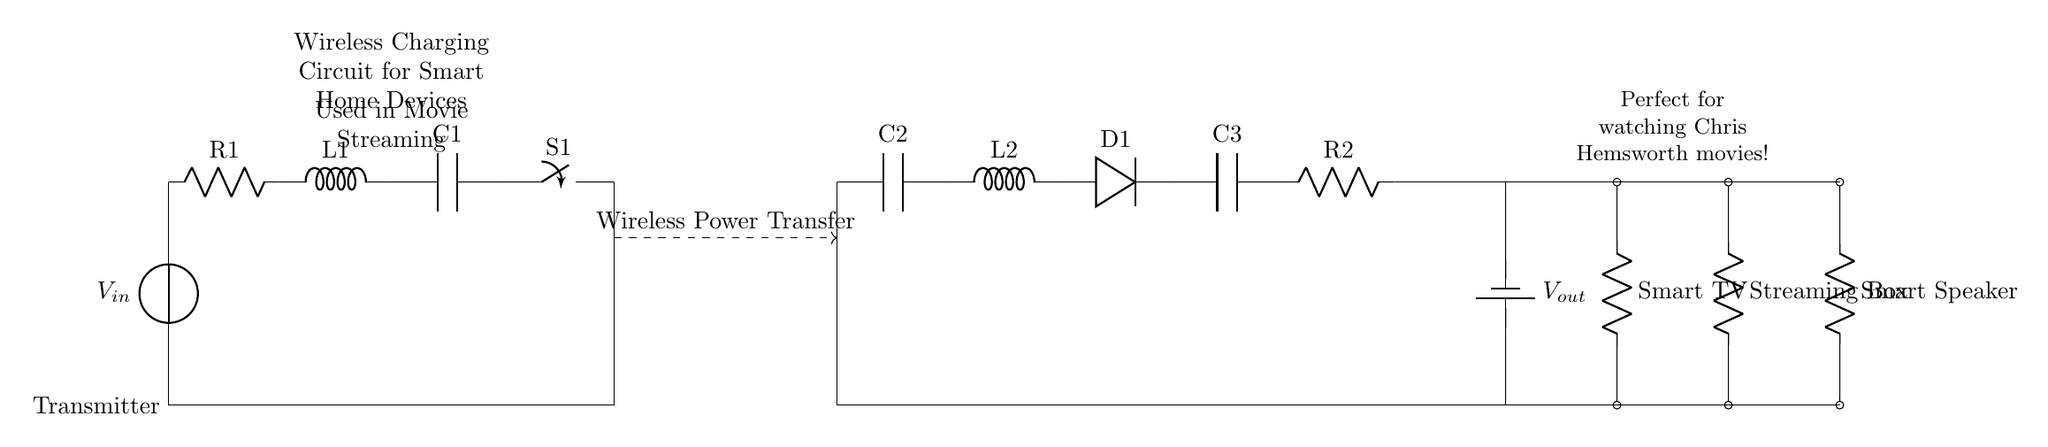What is the function of C1 in the circuit? C1 is a capacitor that is part of the transmitter section, and its role typically involves smoothing out voltage fluctuations and storing energy to ensure stable voltage levels throughout the charging process.
Answer: Capacitor What components are used on the transmitter side? The transmitter side has a voltage source, resistor R1, inductor L1, capacitor C1, a switch S1, and an antenna. Each component plays a role in generating and regulating the wireless power transfer.
Answer: Voltage source, resistor, inductor, capacitor, switch, antenna What is the voltage at the output? The output voltage is indicated as \( V_{out} \) in the circuit diagram, which suggests that it is delivered to the connected smart home devices. To provide a numerical value, one would typically refer to the specifications or measurements system used in the application.
Answer: \( V_{out} \) Which components are included in the receiver section? The receiver section contains an antenna, capacitor C2, inductor L2, diode D1, capacitor C3, and resistor R2. These components are important for capturing the wireless energy and converting it into usable power for devices.
Answer: Antenna, capacitors, inductor, diode, resistor How is wireless energy transmitted from the transmitter to the receiver? Wireless energy is transmitted through the dashed line labeled 'Wireless Power Transfer', which denotes the electromagnetic field created by the transmitter that interacts with the receiver's antenna, enabling power transfer without direct physical connections.
Answer: Antenna What type of circuit is shown in the diagram? The circuit illustrated is a wireless charging circuit designed for smart home devices, showcasing the capability to transfer power harnessed from a charging station to devices like a smart TV, streaming box, and smart speaker.
Answer: Wireless charging circuit 